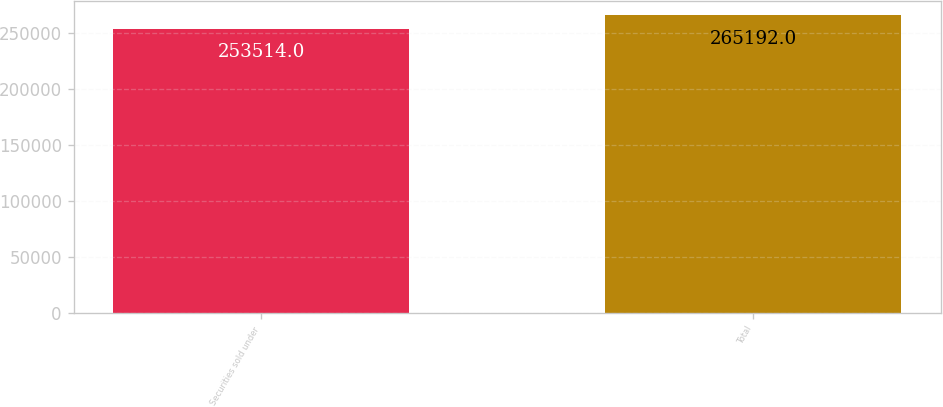Convert chart. <chart><loc_0><loc_0><loc_500><loc_500><bar_chart><fcel>Securities sold under<fcel>Total<nl><fcel>253514<fcel>265192<nl></chart> 